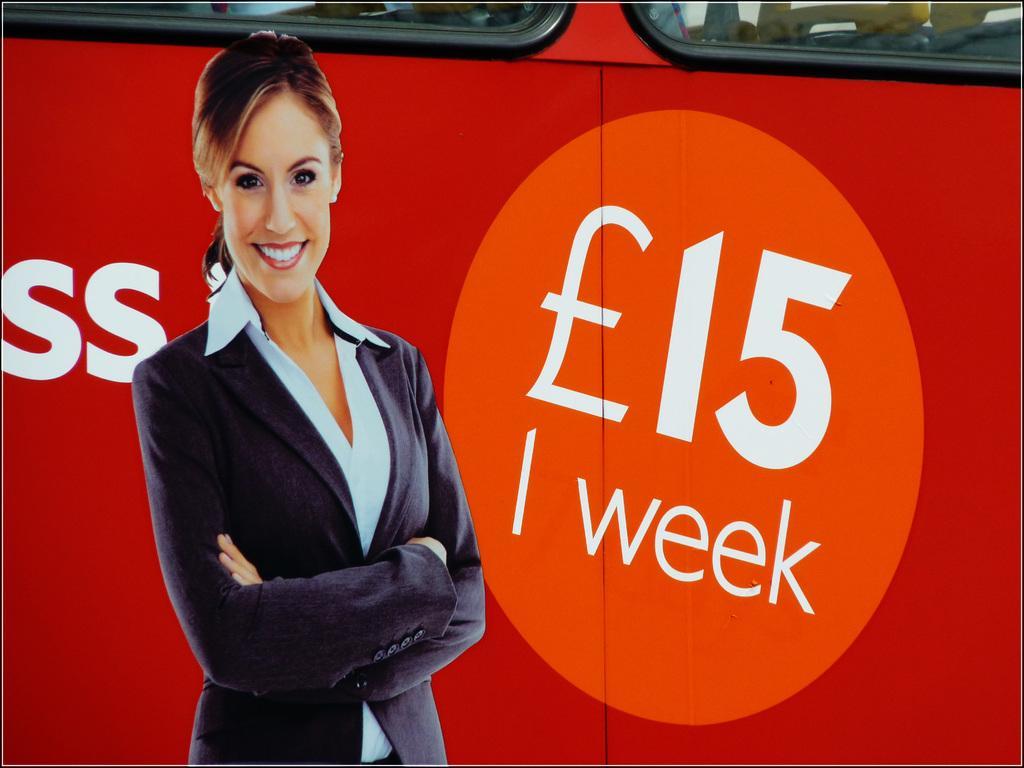Could you give a brief overview of what you see in this image? In this image, we can see a lady standing and smiling and in the background, there is a vehicle. 